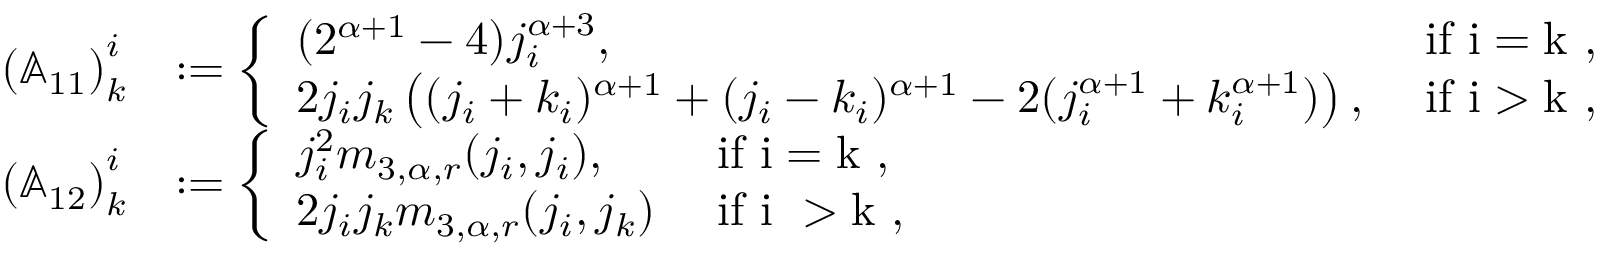Convert formula to latex. <formula><loc_0><loc_0><loc_500><loc_500>\begin{array} { r l } { \left ( \mathbb { A } _ { 1 1 } \right ) _ { k } ^ { i } } & { \colon = \left \{ \begin{array} { l l } { ( 2 ^ { \alpha + 1 } - 4 ) j _ { i } ^ { \alpha + 3 } , } & { i f i = k , } \\ { 2 j _ { i } j _ { k } \left ( ( j _ { i } + k _ { i } ) ^ { \alpha + 1 } + ( j _ { i } - k _ { i } ) ^ { \alpha + 1 } - 2 ( j _ { i } ^ { \alpha + 1 } + k _ { i } ^ { \alpha + 1 } ) \right ) , } & { i f i > k , } \end{array} } \\ { \left ( \mathbb { A } _ { 1 2 } \right ) _ { k } ^ { i } } & { \colon = \left \{ \begin{array} { l l } { j _ { i } ^ { 2 } m _ { 3 , \alpha , r } ( j _ { i } , j _ { i } ) , } & { i f i = k , } \\ { 2 j _ { i } j _ { k } m _ { 3 , \alpha , r } ( j _ { i } , j _ { k } ) } & { i f i > k , } \end{array} } \end{array}</formula> 